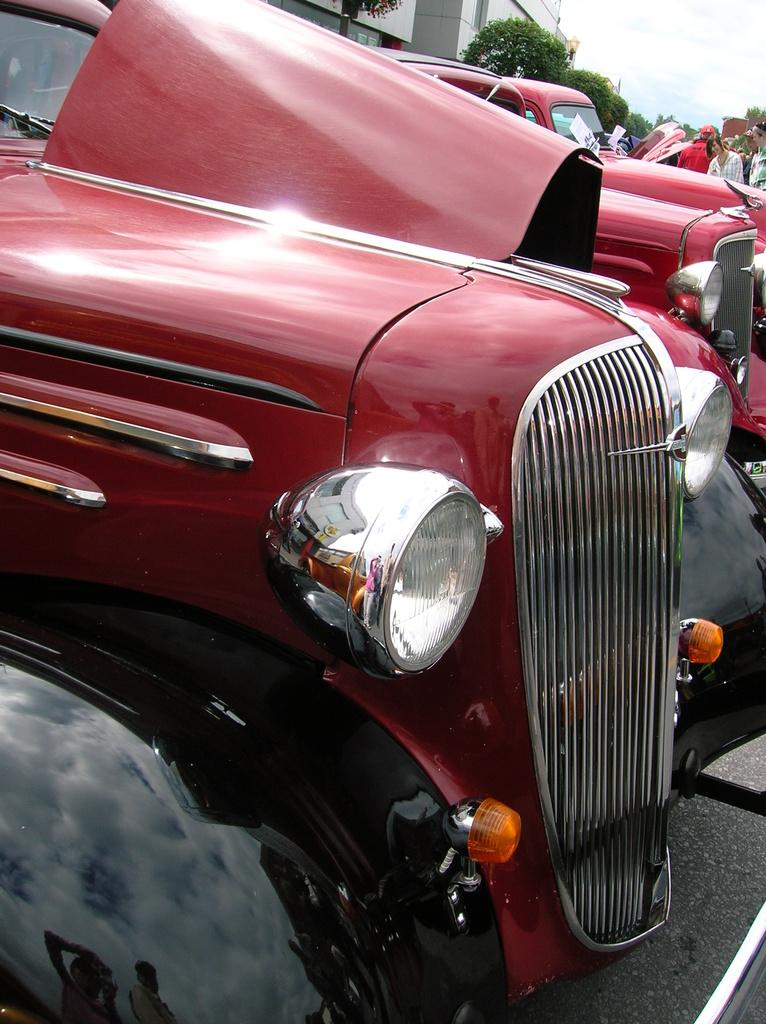What can be seen in the foreground of the picture? There are cars in the foreground of the picture. Where are the people located in the picture? The people are on the right side of the picture. What is visible in the background of the picture? There are trees, buildings, and the sky visible in the background of the picture. Can you see a tent in the picture? There is no tent present in the picture. What type of bottle is being used by the people in the picture? There is no bottle visible in the picture. 